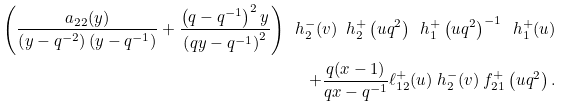<formula> <loc_0><loc_0><loc_500><loc_500>\left ( \frac { a _ { 2 2 } ( y ) } { \left ( y - q ^ { - 2 } \right ) \left ( y - q ^ { - 1 } \right ) } + \frac { \left ( q - q ^ { - 1 } \right ) ^ { 2 } y } { \left ( q y - q ^ { - 1 } \right ) ^ { 2 } } \right ) \ h _ { 2 } ^ { - } ( v ) \ h _ { 2 } ^ { + } \left ( u q ^ { 2 } \right ) \ h _ { 1 } ^ { + } \left ( u q ^ { 2 } \right ) ^ { - 1 } \ h _ { 1 } ^ { + } ( u ) \\ + \frac { q ( x - 1 ) } { q x - q ^ { - 1 } } \ell _ { 1 2 } ^ { + } ( u ) \ h _ { 2 } ^ { - } ( v ) \ f _ { 2 1 } ^ { + } \left ( u q ^ { 2 } \right ) .</formula> 